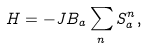Convert formula to latex. <formula><loc_0><loc_0><loc_500><loc_500>H = - { J } B _ { a } \sum _ { n } S _ { a } ^ { n } ,</formula> 